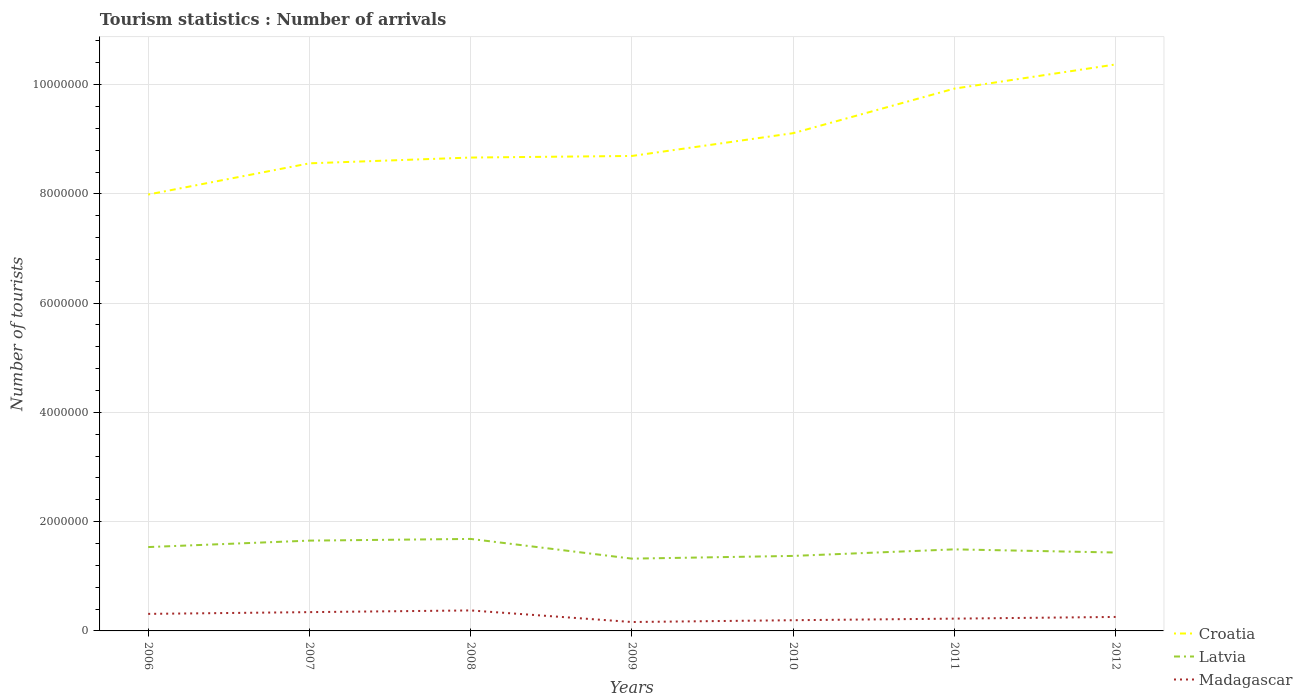How many different coloured lines are there?
Ensure brevity in your answer.  3. Does the line corresponding to Madagascar intersect with the line corresponding to Croatia?
Your answer should be compact. No. Across all years, what is the maximum number of tourist arrivals in Croatia?
Your answer should be very brief. 7.99e+06. What is the total number of tourist arrivals in Croatia in the graph?
Provide a short and direct response. -1.26e+06. What is the difference between the highest and the second highest number of tourist arrivals in Latvia?
Provide a short and direct response. 3.61e+05. What is the difference between the highest and the lowest number of tourist arrivals in Croatia?
Provide a short and direct response. 3. Is the number of tourist arrivals in Latvia strictly greater than the number of tourist arrivals in Croatia over the years?
Your answer should be compact. Yes. How many lines are there?
Ensure brevity in your answer.  3. How many years are there in the graph?
Offer a terse response. 7. Are the values on the major ticks of Y-axis written in scientific E-notation?
Offer a terse response. No. Does the graph contain any zero values?
Your response must be concise. No. Does the graph contain grids?
Your response must be concise. Yes. Where does the legend appear in the graph?
Ensure brevity in your answer.  Bottom right. How are the legend labels stacked?
Make the answer very short. Vertical. What is the title of the graph?
Provide a succinct answer. Tourism statistics : Number of arrivals. What is the label or title of the Y-axis?
Provide a short and direct response. Number of tourists. What is the Number of tourists of Croatia in 2006?
Your answer should be very brief. 7.99e+06. What is the Number of tourists of Latvia in 2006?
Provide a succinct answer. 1.54e+06. What is the Number of tourists of Madagascar in 2006?
Offer a very short reply. 3.12e+05. What is the Number of tourists in Croatia in 2007?
Your answer should be compact. 8.56e+06. What is the Number of tourists of Latvia in 2007?
Your answer should be compact. 1.65e+06. What is the Number of tourists of Madagascar in 2007?
Offer a very short reply. 3.44e+05. What is the Number of tourists in Croatia in 2008?
Your answer should be very brief. 8.66e+06. What is the Number of tourists in Latvia in 2008?
Give a very brief answer. 1.68e+06. What is the Number of tourists in Madagascar in 2008?
Give a very brief answer. 3.75e+05. What is the Number of tourists of Croatia in 2009?
Your response must be concise. 8.69e+06. What is the Number of tourists of Latvia in 2009?
Make the answer very short. 1.32e+06. What is the Number of tourists in Madagascar in 2009?
Offer a very short reply. 1.63e+05. What is the Number of tourists of Croatia in 2010?
Provide a short and direct response. 9.11e+06. What is the Number of tourists of Latvia in 2010?
Your response must be concise. 1.37e+06. What is the Number of tourists in Madagascar in 2010?
Your answer should be compact. 1.96e+05. What is the Number of tourists of Croatia in 2011?
Make the answer very short. 9.93e+06. What is the Number of tourists in Latvia in 2011?
Provide a succinct answer. 1.49e+06. What is the Number of tourists of Madagascar in 2011?
Offer a very short reply. 2.25e+05. What is the Number of tourists in Croatia in 2012?
Give a very brief answer. 1.04e+07. What is the Number of tourists of Latvia in 2012?
Make the answer very short. 1.44e+06. What is the Number of tourists in Madagascar in 2012?
Make the answer very short. 2.56e+05. Across all years, what is the maximum Number of tourists of Croatia?
Provide a succinct answer. 1.04e+07. Across all years, what is the maximum Number of tourists of Latvia?
Keep it short and to the point. 1.68e+06. Across all years, what is the maximum Number of tourists in Madagascar?
Offer a very short reply. 3.75e+05. Across all years, what is the minimum Number of tourists of Croatia?
Provide a succinct answer. 7.99e+06. Across all years, what is the minimum Number of tourists of Latvia?
Provide a short and direct response. 1.32e+06. Across all years, what is the minimum Number of tourists of Madagascar?
Your response must be concise. 1.63e+05. What is the total Number of tourists in Croatia in the graph?
Your answer should be compact. 6.33e+07. What is the total Number of tourists in Latvia in the graph?
Your answer should be very brief. 1.05e+07. What is the total Number of tourists of Madagascar in the graph?
Provide a succinct answer. 1.87e+06. What is the difference between the Number of tourists of Croatia in 2006 and that in 2007?
Offer a very short reply. -5.71e+05. What is the difference between the Number of tourists in Latvia in 2006 and that in 2007?
Your answer should be compact. -1.18e+05. What is the difference between the Number of tourists of Madagascar in 2006 and that in 2007?
Keep it short and to the point. -3.20e+04. What is the difference between the Number of tourists in Croatia in 2006 and that in 2008?
Ensure brevity in your answer.  -6.77e+05. What is the difference between the Number of tourists in Latvia in 2006 and that in 2008?
Your answer should be compact. -1.49e+05. What is the difference between the Number of tourists in Madagascar in 2006 and that in 2008?
Keep it short and to the point. -6.30e+04. What is the difference between the Number of tourists of Croatia in 2006 and that in 2009?
Your response must be concise. -7.06e+05. What is the difference between the Number of tourists in Latvia in 2006 and that in 2009?
Your answer should be compact. 2.12e+05. What is the difference between the Number of tourists of Madagascar in 2006 and that in 2009?
Provide a short and direct response. 1.49e+05. What is the difference between the Number of tourists of Croatia in 2006 and that in 2010?
Keep it short and to the point. -1.12e+06. What is the difference between the Number of tourists of Latvia in 2006 and that in 2010?
Offer a very short reply. 1.62e+05. What is the difference between the Number of tourists in Madagascar in 2006 and that in 2010?
Offer a very short reply. 1.16e+05. What is the difference between the Number of tourists in Croatia in 2006 and that in 2011?
Offer a terse response. -1.94e+06. What is the difference between the Number of tourists of Latvia in 2006 and that in 2011?
Provide a succinct answer. 4.20e+04. What is the difference between the Number of tourists in Madagascar in 2006 and that in 2011?
Your answer should be compact. 8.70e+04. What is the difference between the Number of tourists in Croatia in 2006 and that in 2012?
Your response must be concise. -2.38e+06. What is the difference between the Number of tourists in Madagascar in 2006 and that in 2012?
Your answer should be compact. 5.60e+04. What is the difference between the Number of tourists of Croatia in 2007 and that in 2008?
Give a very brief answer. -1.06e+05. What is the difference between the Number of tourists of Latvia in 2007 and that in 2008?
Your answer should be compact. -3.10e+04. What is the difference between the Number of tourists of Madagascar in 2007 and that in 2008?
Ensure brevity in your answer.  -3.10e+04. What is the difference between the Number of tourists of Croatia in 2007 and that in 2009?
Offer a very short reply. -1.35e+05. What is the difference between the Number of tourists in Madagascar in 2007 and that in 2009?
Ensure brevity in your answer.  1.81e+05. What is the difference between the Number of tourists in Croatia in 2007 and that in 2010?
Offer a very short reply. -5.52e+05. What is the difference between the Number of tourists in Madagascar in 2007 and that in 2010?
Offer a very short reply. 1.48e+05. What is the difference between the Number of tourists of Croatia in 2007 and that in 2011?
Your answer should be very brief. -1.37e+06. What is the difference between the Number of tourists of Latvia in 2007 and that in 2011?
Your response must be concise. 1.60e+05. What is the difference between the Number of tourists of Madagascar in 2007 and that in 2011?
Offer a terse response. 1.19e+05. What is the difference between the Number of tourists in Croatia in 2007 and that in 2012?
Your answer should be compact. -1.81e+06. What is the difference between the Number of tourists of Latvia in 2007 and that in 2012?
Provide a succinct answer. 2.18e+05. What is the difference between the Number of tourists in Madagascar in 2007 and that in 2012?
Your answer should be compact. 8.80e+04. What is the difference between the Number of tourists of Croatia in 2008 and that in 2009?
Offer a very short reply. -2.90e+04. What is the difference between the Number of tourists of Latvia in 2008 and that in 2009?
Make the answer very short. 3.61e+05. What is the difference between the Number of tourists of Madagascar in 2008 and that in 2009?
Offer a very short reply. 2.12e+05. What is the difference between the Number of tourists in Croatia in 2008 and that in 2010?
Offer a very short reply. -4.46e+05. What is the difference between the Number of tourists in Latvia in 2008 and that in 2010?
Ensure brevity in your answer.  3.11e+05. What is the difference between the Number of tourists of Madagascar in 2008 and that in 2010?
Your answer should be very brief. 1.79e+05. What is the difference between the Number of tourists of Croatia in 2008 and that in 2011?
Make the answer very short. -1.26e+06. What is the difference between the Number of tourists of Latvia in 2008 and that in 2011?
Give a very brief answer. 1.91e+05. What is the difference between the Number of tourists in Croatia in 2008 and that in 2012?
Provide a succinct answer. -1.70e+06. What is the difference between the Number of tourists of Latvia in 2008 and that in 2012?
Your answer should be compact. 2.49e+05. What is the difference between the Number of tourists in Madagascar in 2008 and that in 2012?
Give a very brief answer. 1.19e+05. What is the difference between the Number of tourists in Croatia in 2009 and that in 2010?
Ensure brevity in your answer.  -4.17e+05. What is the difference between the Number of tourists of Latvia in 2009 and that in 2010?
Offer a terse response. -5.00e+04. What is the difference between the Number of tourists in Madagascar in 2009 and that in 2010?
Your answer should be compact. -3.30e+04. What is the difference between the Number of tourists in Croatia in 2009 and that in 2011?
Make the answer very short. -1.23e+06. What is the difference between the Number of tourists in Latvia in 2009 and that in 2011?
Your answer should be very brief. -1.70e+05. What is the difference between the Number of tourists of Madagascar in 2009 and that in 2011?
Provide a short and direct response. -6.20e+04. What is the difference between the Number of tourists in Croatia in 2009 and that in 2012?
Keep it short and to the point. -1.68e+06. What is the difference between the Number of tourists of Latvia in 2009 and that in 2012?
Give a very brief answer. -1.12e+05. What is the difference between the Number of tourists in Madagascar in 2009 and that in 2012?
Provide a succinct answer. -9.30e+04. What is the difference between the Number of tourists of Croatia in 2010 and that in 2011?
Provide a short and direct response. -8.16e+05. What is the difference between the Number of tourists of Madagascar in 2010 and that in 2011?
Your answer should be compact. -2.90e+04. What is the difference between the Number of tourists of Croatia in 2010 and that in 2012?
Provide a short and direct response. -1.26e+06. What is the difference between the Number of tourists of Latvia in 2010 and that in 2012?
Provide a succinct answer. -6.20e+04. What is the difference between the Number of tourists of Croatia in 2011 and that in 2012?
Offer a terse response. -4.42e+05. What is the difference between the Number of tourists in Latvia in 2011 and that in 2012?
Keep it short and to the point. 5.80e+04. What is the difference between the Number of tourists in Madagascar in 2011 and that in 2012?
Offer a terse response. -3.10e+04. What is the difference between the Number of tourists in Croatia in 2006 and the Number of tourists in Latvia in 2007?
Give a very brief answer. 6.34e+06. What is the difference between the Number of tourists of Croatia in 2006 and the Number of tourists of Madagascar in 2007?
Ensure brevity in your answer.  7.64e+06. What is the difference between the Number of tourists of Latvia in 2006 and the Number of tourists of Madagascar in 2007?
Provide a short and direct response. 1.19e+06. What is the difference between the Number of tourists of Croatia in 2006 and the Number of tourists of Latvia in 2008?
Your response must be concise. 6.30e+06. What is the difference between the Number of tourists of Croatia in 2006 and the Number of tourists of Madagascar in 2008?
Make the answer very short. 7.61e+06. What is the difference between the Number of tourists in Latvia in 2006 and the Number of tourists in Madagascar in 2008?
Give a very brief answer. 1.16e+06. What is the difference between the Number of tourists in Croatia in 2006 and the Number of tourists in Latvia in 2009?
Make the answer very short. 6.66e+06. What is the difference between the Number of tourists of Croatia in 2006 and the Number of tourists of Madagascar in 2009?
Provide a succinct answer. 7.82e+06. What is the difference between the Number of tourists of Latvia in 2006 and the Number of tourists of Madagascar in 2009?
Make the answer very short. 1.37e+06. What is the difference between the Number of tourists in Croatia in 2006 and the Number of tourists in Latvia in 2010?
Offer a very short reply. 6.62e+06. What is the difference between the Number of tourists of Croatia in 2006 and the Number of tourists of Madagascar in 2010?
Your response must be concise. 7.79e+06. What is the difference between the Number of tourists of Latvia in 2006 and the Number of tourists of Madagascar in 2010?
Keep it short and to the point. 1.34e+06. What is the difference between the Number of tourists in Croatia in 2006 and the Number of tourists in Latvia in 2011?
Your answer should be very brief. 6.50e+06. What is the difference between the Number of tourists in Croatia in 2006 and the Number of tourists in Madagascar in 2011?
Provide a short and direct response. 7.76e+06. What is the difference between the Number of tourists of Latvia in 2006 and the Number of tourists of Madagascar in 2011?
Offer a very short reply. 1.31e+06. What is the difference between the Number of tourists in Croatia in 2006 and the Number of tourists in Latvia in 2012?
Provide a short and direct response. 6.55e+06. What is the difference between the Number of tourists of Croatia in 2006 and the Number of tourists of Madagascar in 2012?
Offer a very short reply. 7.73e+06. What is the difference between the Number of tourists of Latvia in 2006 and the Number of tourists of Madagascar in 2012?
Keep it short and to the point. 1.28e+06. What is the difference between the Number of tourists in Croatia in 2007 and the Number of tourists in Latvia in 2008?
Offer a very short reply. 6.88e+06. What is the difference between the Number of tourists in Croatia in 2007 and the Number of tourists in Madagascar in 2008?
Give a very brief answer. 8.18e+06. What is the difference between the Number of tourists of Latvia in 2007 and the Number of tourists of Madagascar in 2008?
Your response must be concise. 1.28e+06. What is the difference between the Number of tourists of Croatia in 2007 and the Number of tourists of Latvia in 2009?
Provide a short and direct response. 7.24e+06. What is the difference between the Number of tourists of Croatia in 2007 and the Number of tourists of Madagascar in 2009?
Ensure brevity in your answer.  8.40e+06. What is the difference between the Number of tourists in Latvia in 2007 and the Number of tourists in Madagascar in 2009?
Provide a succinct answer. 1.49e+06. What is the difference between the Number of tourists of Croatia in 2007 and the Number of tourists of Latvia in 2010?
Your response must be concise. 7.19e+06. What is the difference between the Number of tourists in Croatia in 2007 and the Number of tourists in Madagascar in 2010?
Make the answer very short. 8.36e+06. What is the difference between the Number of tourists in Latvia in 2007 and the Number of tourists in Madagascar in 2010?
Your response must be concise. 1.46e+06. What is the difference between the Number of tourists in Croatia in 2007 and the Number of tourists in Latvia in 2011?
Your response must be concise. 7.07e+06. What is the difference between the Number of tourists of Croatia in 2007 and the Number of tourists of Madagascar in 2011?
Give a very brief answer. 8.33e+06. What is the difference between the Number of tourists in Latvia in 2007 and the Number of tourists in Madagascar in 2011?
Offer a terse response. 1.43e+06. What is the difference between the Number of tourists in Croatia in 2007 and the Number of tourists in Latvia in 2012?
Give a very brief answer. 7.12e+06. What is the difference between the Number of tourists in Croatia in 2007 and the Number of tourists in Madagascar in 2012?
Your answer should be compact. 8.30e+06. What is the difference between the Number of tourists in Latvia in 2007 and the Number of tourists in Madagascar in 2012?
Keep it short and to the point. 1.40e+06. What is the difference between the Number of tourists of Croatia in 2008 and the Number of tourists of Latvia in 2009?
Ensure brevity in your answer.  7.34e+06. What is the difference between the Number of tourists of Croatia in 2008 and the Number of tourists of Madagascar in 2009?
Ensure brevity in your answer.  8.50e+06. What is the difference between the Number of tourists in Latvia in 2008 and the Number of tourists in Madagascar in 2009?
Offer a terse response. 1.52e+06. What is the difference between the Number of tourists of Croatia in 2008 and the Number of tourists of Latvia in 2010?
Give a very brief answer. 7.29e+06. What is the difference between the Number of tourists in Croatia in 2008 and the Number of tourists in Madagascar in 2010?
Your response must be concise. 8.47e+06. What is the difference between the Number of tourists in Latvia in 2008 and the Number of tourists in Madagascar in 2010?
Offer a very short reply. 1.49e+06. What is the difference between the Number of tourists in Croatia in 2008 and the Number of tourists in Latvia in 2011?
Provide a short and direct response. 7.17e+06. What is the difference between the Number of tourists in Croatia in 2008 and the Number of tourists in Madagascar in 2011?
Your response must be concise. 8.44e+06. What is the difference between the Number of tourists in Latvia in 2008 and the Number of tourists in Madagascar in 2011?
Make the answer very short. 1.46e+06. What is the difference between the Number of tourists in Croatia in 2008 and the Number of tourists in Latvia in 2012?
Your response must be concise. 7.23e+06. What is the difference between the Number of tourists of Croatia in 2008 and the Number of tourists of Madagascar in 2012?
Offer a terse response. 8.41e+06. What is the difference between the Number of tourists of Latvia in 2008 and the Number of tourists of Madagascar in 2012?
Provide a short and direct response. 1.43e+06. What is the difference between the Number of tourists in Croatia in 2009 and the Number of tourists in Latvia in 2010?
Offer a very short reply. 7.32e+06. What is the difference between the Number of tourists of Croatia in 2009 and the Number of tourists of Madagascar in 2010?
Ensure brevity in your answer.  8.50e+06. What is the difference between the Number of tourists in Latvia in 2009 and the Number of tourists in Madagascar in 2010?
Your response must be concise. 1.13e+06. What is the difference between the Number of tourists of Croatia in 2009 and the Number of tourists of Latvia in 2011?
Give a very brief answer. 7.20e+06. What is the difference between the Number of tourists of Croatia in 2009 and the Number of tourists of Madagascar in 2011?
Your answer should be very brief. 8.47e+06. What is the difference between the Number of tourists in Latvia in 2009 and the Number of tourists in Madagascar in 2011?
Offer a very short reply. 1.10e+06. What is the difference between the Number of tourists of Croatia in 2009 and the Number of tourists of Latvia in 2012?
Provide a succinct answer. 7.26e+06. What is the difference between the Number of tourists in Croatia in 2009 and the Number of tourists in Madagascar in 2012?
Your answer should be compact. 8.44e+06. What is the difference between the Number of tourists of Latvia in 2009 and the Number of tourists of Madagascar in 2012?
Offer a very short reply. 1.07e+06. What is the difference between the Number of tourists of Croatia in 2010 and the Number of tourists of Latvia in 2011?
Provide a short and direct response. 7.62e+06. What is the difference between the Number of tourists of Croatia in 2010 and the Number of tourists of Madagascar in 2011?
Your response must be concise. 8.89e+06. What is the difference between the Number of tourists of Latvia in 2010 and the Number of tourists of Madagascar in 2011?
Provide a short and direct response. 1.15e+06. What is the difference between the Number of tourists in Croatia in 2010 and the Number of tourists in Latvia in 2012?
Give a very brief answer. 7.68e+06. What is the difference between the Number of tourists of Croatia in 2010 and the Number of tourists of Madagascar in 2012?
Offer a very short reply. 8.86e+06. What is the difference between the Number of tourists in Latvia in 2010 and the Number of tourists in Madagascar in 2012?
Offer a terse response. 1.12e+06. What is the difference between the Number of tourists in Croatia in 2011 and the Number of tourists in Latvia in 2012?
Your answer should be very brief. 8.49e+06. What is the difference between the Number of tourists of Croatia in 2011 and the Number of tourists of Madagascar in 2012?
Ensure brevity in your answer.  9.67e+06. What is the difference between the Number of tourists in Latvia in 2011 and the Number of tourists in Madagascar in 2012?
Provide a succinct answer. 1.24e+06. What is the average Number of tourists in Croatia per year?
Keep it short and to the point. 9.04e+06. What is the average Number of tourists in Latvia per year?
Give a very brief answer. 1.50e+06. What is the average Number of tourists of Madagascar per year?
Make the answer very short. 2.67e+05. In the year 2006, what is the difference between the Number of tourists of Croatia and Number of tourists of Latvia?
Give a very brief answer. 6.45e+06. In the year 2006, what is the difference between the Number of tourists of Croatia and Number of tourists of Madagascar?
Ensure brevity in your answer.  7.68e+06. In the year 2006, what is the difference between the Number of tourists in Latvia and Number of tourists in Madagascar?
Your answer should be compact. 1.22e+06. In the year 2007, what is the difference between the Number of tourists in Croatia and Number of tourists in Latvia?
Offer a terse response. 6.91e+06. In the year 2007, what is the difference between the Number of tourists of Croatia and Number of tourists of Madagascar?
Offer a very short reply. 8.22e+06. In the year 2007, what is the difference between the Number of tourists in Latvia and Number of tourists in Madagascar?
Offer a very short reply. 1.31e+06. In the year 2008, what is the difference between the Number of tourists of Croatia and Number of tourists of Latvia?
Make the answer very short. 6.98e+06. In the year 2008, what is the difference between the Number of tourists of Croatia and Number of tourists of Madagascar?
Provide a succinct answer. 8.29e+06. In the year 2008, what is the difference between the Number of tourists of Latvia and Number of tourists of Madagascar?
Offer a terse response. 1.31e+06. In the year 2009, what is the difference between the Number of tourists of Croatia and Number of tourists of Latvia?
Your answer should be compact. 7.37e+06. In the year 2009, what is the difference between the Number of tourists of Croatia and Number of tourists of Madagascar?
Offer a terse response. 8.53e+06. In the year 2009, what is the difference between the Number of tourists of Latvia and Number of tourists of Madagascar?
Keep it short and to the point. 1.16e+06. In the year 2010, what is the difference between the Number of tourists in Croatia and Number of tourists in Latvia?
Offer a very short reply. 7.74e+06. In the year 2010, what is the difference between the Number of tourists in Croatia and Number of tourists in Madagascar?
Keep it short and to the point. 8.92e+06. In the year 2010, what is the difference between the Number of tourists of Latvia and Number of tourists of Madagascar?
Your response must be concise. 1.18e+06. In the year 2011, what is the difference between the Number of tourists in Croatia and Number of tourists in Latvia?
Keep it short and to the point. 8.43e+06. In the year 2011, what is the difference between the Number of tourists of Croatia and Number of tourists of Madagascar?
Your response must be concise. 9.70e+06. In the year 2011, what is the difference between the Number of tourists in Latvia and Number of tourists in Madagascar?
Provide a succinct answer. 1.27e+06. In the year 2012, what is the difference between the Number of tourists of Croatia and Number of tourists of Latvia?
Offer a very short reply. 8.93e+06. In the year 2012, what is the difference between the Number of tourists in Croatia and Number of tourists in Madagascar?
Your response must be concise. 1.01e+07. In the year 2012, what is the difference between the Number of tourists of Latvia and Number of tourists of Madagascar?
Provide a succinct answer. 1.18e+06. What is the ratio of the Number of tourists in Madagascar in 2006 to that in 2007?
Provide a short and direct response. 0.91. What is the ratio of the Number of tourists in Croatia in 2006 to that in 2008?
Provide a succinct answer. 0.92. What is the ratio of the Number of tourists in Latvia in 2006 to that in 2008?
Your answer should be very brief. 0.91. What is the ratio of the Number of tourists of Madagascar in 2006 to that in 2008?
Provide a short and direct response. 0.83. What is the ratio of the Number of tourists in Croatia in 2006 to that in 2009?
Keep it short and to the point. 0.92. What is the ratio of the Number of tourists of Latvia in 2006 to that in 2009?
Your answer should be very brief. 1.16. What is the ratio of the Number of tourists of Madagascar in 2006 to that in 2009?
Offer a terse response. 1.91. What is the ratio of the Number of tourists of Croatia in 2006 to that in 2010?
Your answer should be compact. 0.88. What is the ratio of the Number of tourists in Latvia in 2006 to that in 2010?
Ensure brevity in your answer.  1.12. What is the ratio of the Number of tourists of Madagascar in 2006 to that in 2010?
Keep it short and to the point. 1.59. What is the ratio of the Number of tourists in Croatia in 2006 to that in 2011?
Offer a very short reply. 0.8. What is the ratio of the Number of tourists in Latvia in 2006 to that in 2011?
Keep it short and to the point. 1.03. What is the ratio of the Number of tourists in Madagascar in 2006 to that in 2011?
Your answer should be very brief. 1.39. What is the ratio of the Number of tourists in Croatia in 2006 to that in 2012?
Keep it short and to the point. 0.77. What is the ratio of the Number of tourists of Latvia in 2006 to that in 2012?
Give a very brief answer. 1.07. What is the ratio of the Number of tourists of Madagascar in 2006 to that in 2012?
Make the answer very short. 1.22. What is the ratio of the Number of tourists of Croatia in 2007 to that in 2008?
Ensure brevity in your answer.  0.99. What is the ratio of the Number of tourists in Latvia in 2007 to that in 2008?
Give a very brief answer. 0.98. What is the ratio of the Number of tourists in Madagascar in 2007 to that in 2008?
Your answer should be very brief. 0.92. What is the ratio of the Number of tourists of Croatia in 2007 to that in 2009?
Provide a succinct answer. 0.98. What is the ratio of the Number of tourists of Latvia in 2007 to that in 2009?
Your answer should be very brief. 1.25. What is the ratio of the Number of tourists in Madagascar in 2007 to that in 2009?
Ensure brevity in your answer.  2.11. What is the ratio of the Number of tourists in Croatia in 2007 to that in 2010?
Your answer should be very brief. 0.94. What is the ratio of the Number of tourists of Latvia in 2007 to that in 2010?
Your answer should be compact. 1.2. What is the ratio of the Number of tourists of Madagascar in 2007 to that in 2010?
Provide a short and direct response. 1.76. What is the ratio of the Number of tourists of Croatia in 2007 to that in 2011?
Provide a succinct answer. 0.86. What is the ratio of the Number of tourists in Latvia in 2007 to that in 2011?
Your response must be concise. 1.11. What is the ratio of the Number of tourists of Madagascar in 2007 to that in 2011?
Offer a terse response. 1.53. What is the ratio of the Number of tourists in Croatia in 2007 to that in 2012?
Offer a terse response. 0.83. What is the ratio of the Number of tourists of Latvia in 2007 to that in 2012?
Your answer should be very brief. 1.15. What is the ratio of the Number of tourists in Madagascar in 2007 to that in 2012?
Ensure brevity in your answer.  1.34. What is the ratio of the Number of tourists of Latvia in 2008 to that in 2009?
Ensure brevity in your answer.  1.27. What is the ratio of the Number of tourists of Madagascar in 2008 to that in 2009?
Provide a short and direct response. 2.3. What is the ratio of the Number of tourists in Croatia in 2008 to that in 2010?
Make the answer very short. 0.95. What is the ratio of the Number of tourists of Latvia in 2008 to that in 2010?
Your answer should be very brief. 1.23. What is the ratio of the Number of tourists in Madagascar in 2008 to that in 2010?
Your answer should be compact. 1.91. What is the ratio of the Number of tourists in Croatia in 2008 to that in 2011?
Provide a succinct answer. 0.87. What is the ratio of the Number of tourists in Latvia in 2008 to that in 2011?
Your answer should be very brief. 1.13. What is the ratio of the Number of tourists in Madagascar in 2008 to that in 2011?
Provide a short and direct response. 1.67. What is the ratio of the Number of tourists of Croatia in 2008 to that in 2012?
Your answer should be compact. 0.84. What is the ratio of the Number of tourists in Latvia in 2008 to that in 2012?
Provide a succinct answer. 1.17. What is the ratio of the Number of tourists in Madagascar in 2008 to that in 2012?
Offer a very short reply. 1.46. What is the ratio of the Number of tourists of Croatia in 2009 to that in 2010?
Make the answer very short. 0.95. What is the ratio of the Number of tourists in Latvia in 2009 to that in 2010?
Provide a succinct answer. 0.96. What is the ratio of the Number of tourists in Madagascar in 2009 to that in 2010?
Ensure brevity in your answer.  0.83. What is the ratio of the Number of tourists of Croatia in 2009 to that in 2011?
Give a very brief answer. 0.88. What is the ratio of the Number of tourists of Latvia in 2009 to that in 2011?
Make the answer very short. 0.89. What is the ratio of the Number of tourists of Madagascar in 2009 to that in 2011?
Provide a succinct answer. 0.72. What is the ratio of the Number of tourists of Croatia in 2009 to that in 2012?
Offer a terse response. 0.84. What is the ratio of the Number of tourists in Latvia in 2009 to that in 2012?
Your answer should be very brief. 0.92. What is the ratio of the Number of tourists of Madagascar in 2009 to that in 2012?
Keep it short and to the point. 0.64. What is the ratio of the Number of tourists of Croatia in 2010 to that in 2011?
Provide a succinct answer. 0.92. What is the ratio of the Number of tourists of Latvia in 2010 to that in 2011?
Provide a succinct answer. 0.92. What is the ratio of the Number of tourists of Madagascar in 2010 to that in 2011?
Give a very brief answer. 0.87. What is the ratio of the Number of tourists of Croatia in 2010 to that in 2012?
Your response must be concise. 0.88. What is the ratio of the Number of tourists of Latvia in 2010 to that in 2012?
Give a very brief answer. 0.96. What is the ratio of the Number of tourists in Madagascar in 2010 to that in 2012?
Give a very brief answer. 0.77. What is the ratio of the Number of tourists in Croatia in 2011 to that in 2012?
Your answer should be very brief. 0.96. What is the ratio of the Number of tourists in Latvia in 2011 to that in 2012?
Your answer should be compact. 1.04. What is the ratio of the Number of tourists of Madagascar in 2011 to that in 2012?
Keep it short and to the point. 0.88. What is the difference between the highest and the second highest Number of tourists in Croatia?
Provide a succinct answer. 4.42e+05. What is the difference between the highest and the second highest Number of tourists of Latvia?
Your answer should be compact. 3.10e+04. What is the difference between the highest and the second highest Number of tourists of Madagascar?
Offer a terse response. 3.10e+04. What is the difference between the highest and the lowest Number of tourists of Croatia?
Provide a succinct answer. 2.38e+06. What is the difference between the highest and the lowest Number of tourists in Latvia?
Provide a short and direct response. 3.61e+05. What is the difference between the highest and the lowest Number of tourists of Madagascar?
Make the answer very short. 2.12e+05. 